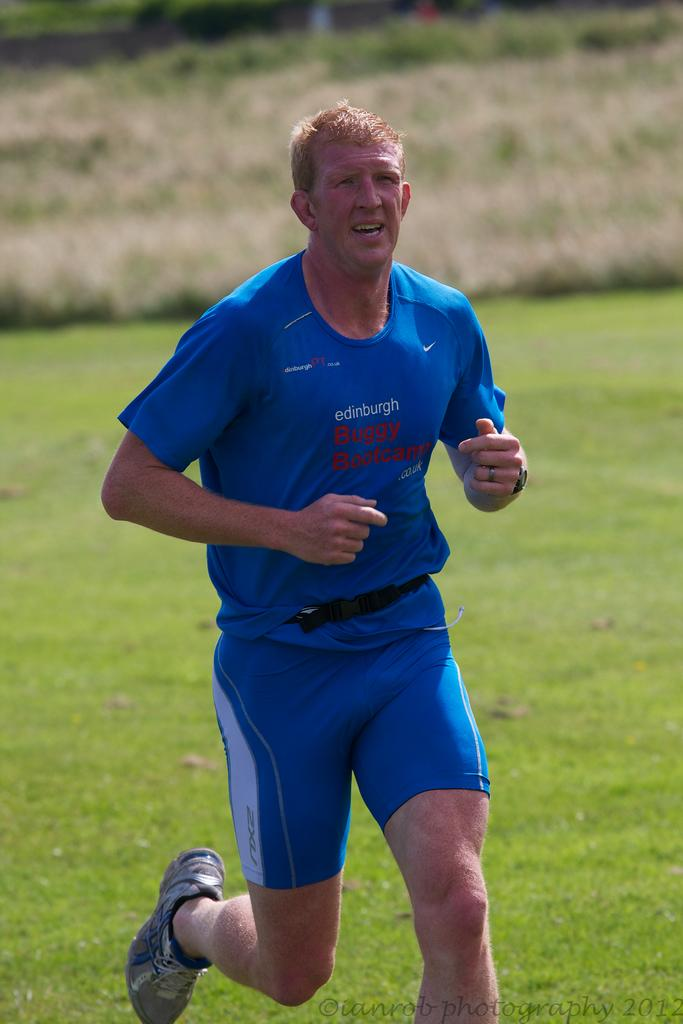What is the man in the image doing? The man is running in the image. What surface is the man running on? The man is running on the ground. What type of vegetation can be seen in the image? There is grass visible in the image. What structure is present in the image? There is a wall in the image. What can be found at the bottom of the image? There is text at the bottom of the image. What type of plants can be seen growing on the man's tongue in the image? There is no mention of a man's tongue or plants growing on it in the image. 